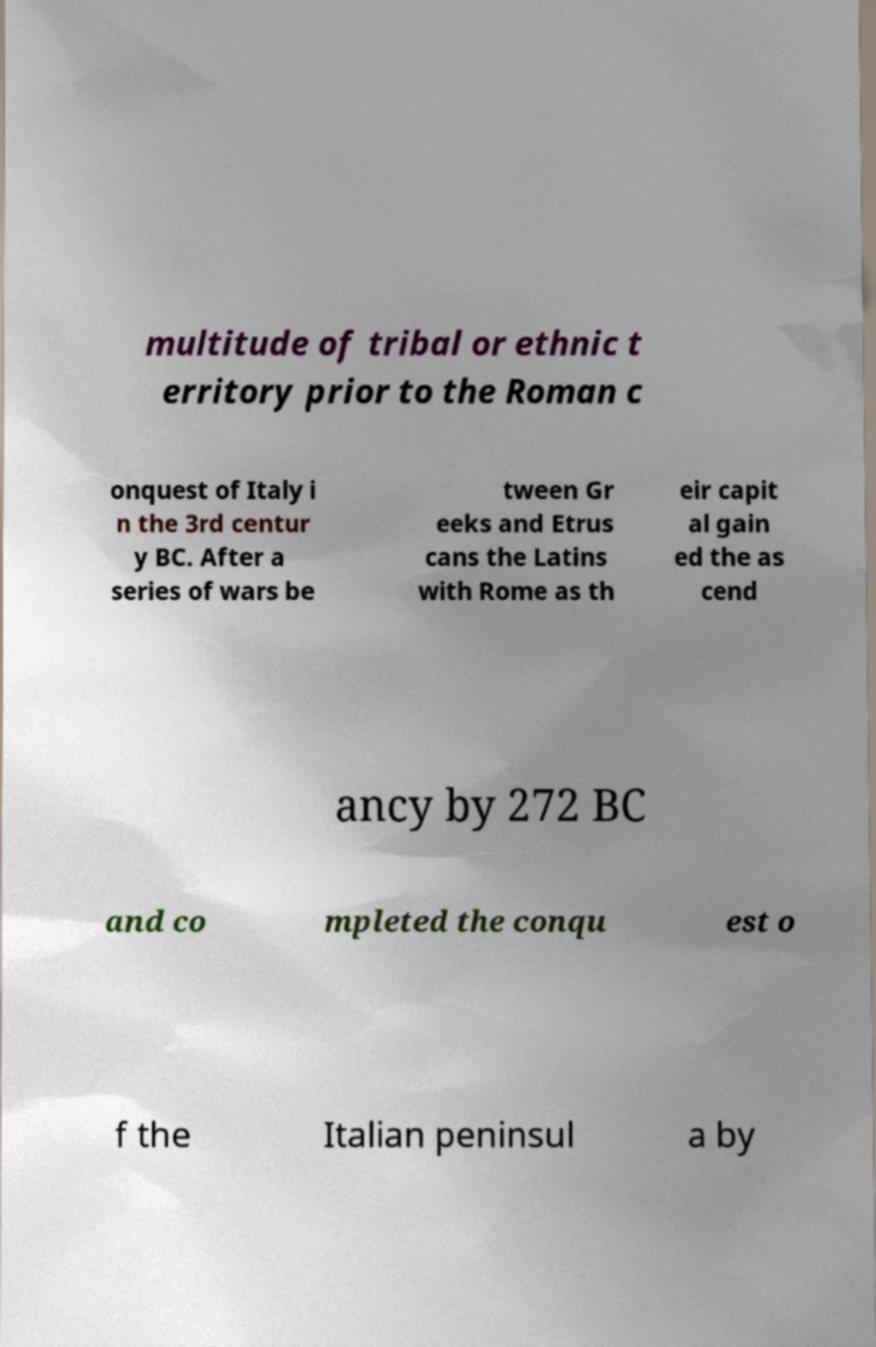Could you extract and type out the text from this image? multitude of tribal or ethnic t erritory prior to the Roman c onquest of Italy i n the 3rd centur y BC. After a series of wars be tween Gr eeks and Etrus cans the Latins with Rome as th eir capit al gain ed the as cend ancy by 272 BC and co mpleted the conqu est o f the Italian peninsul a by 